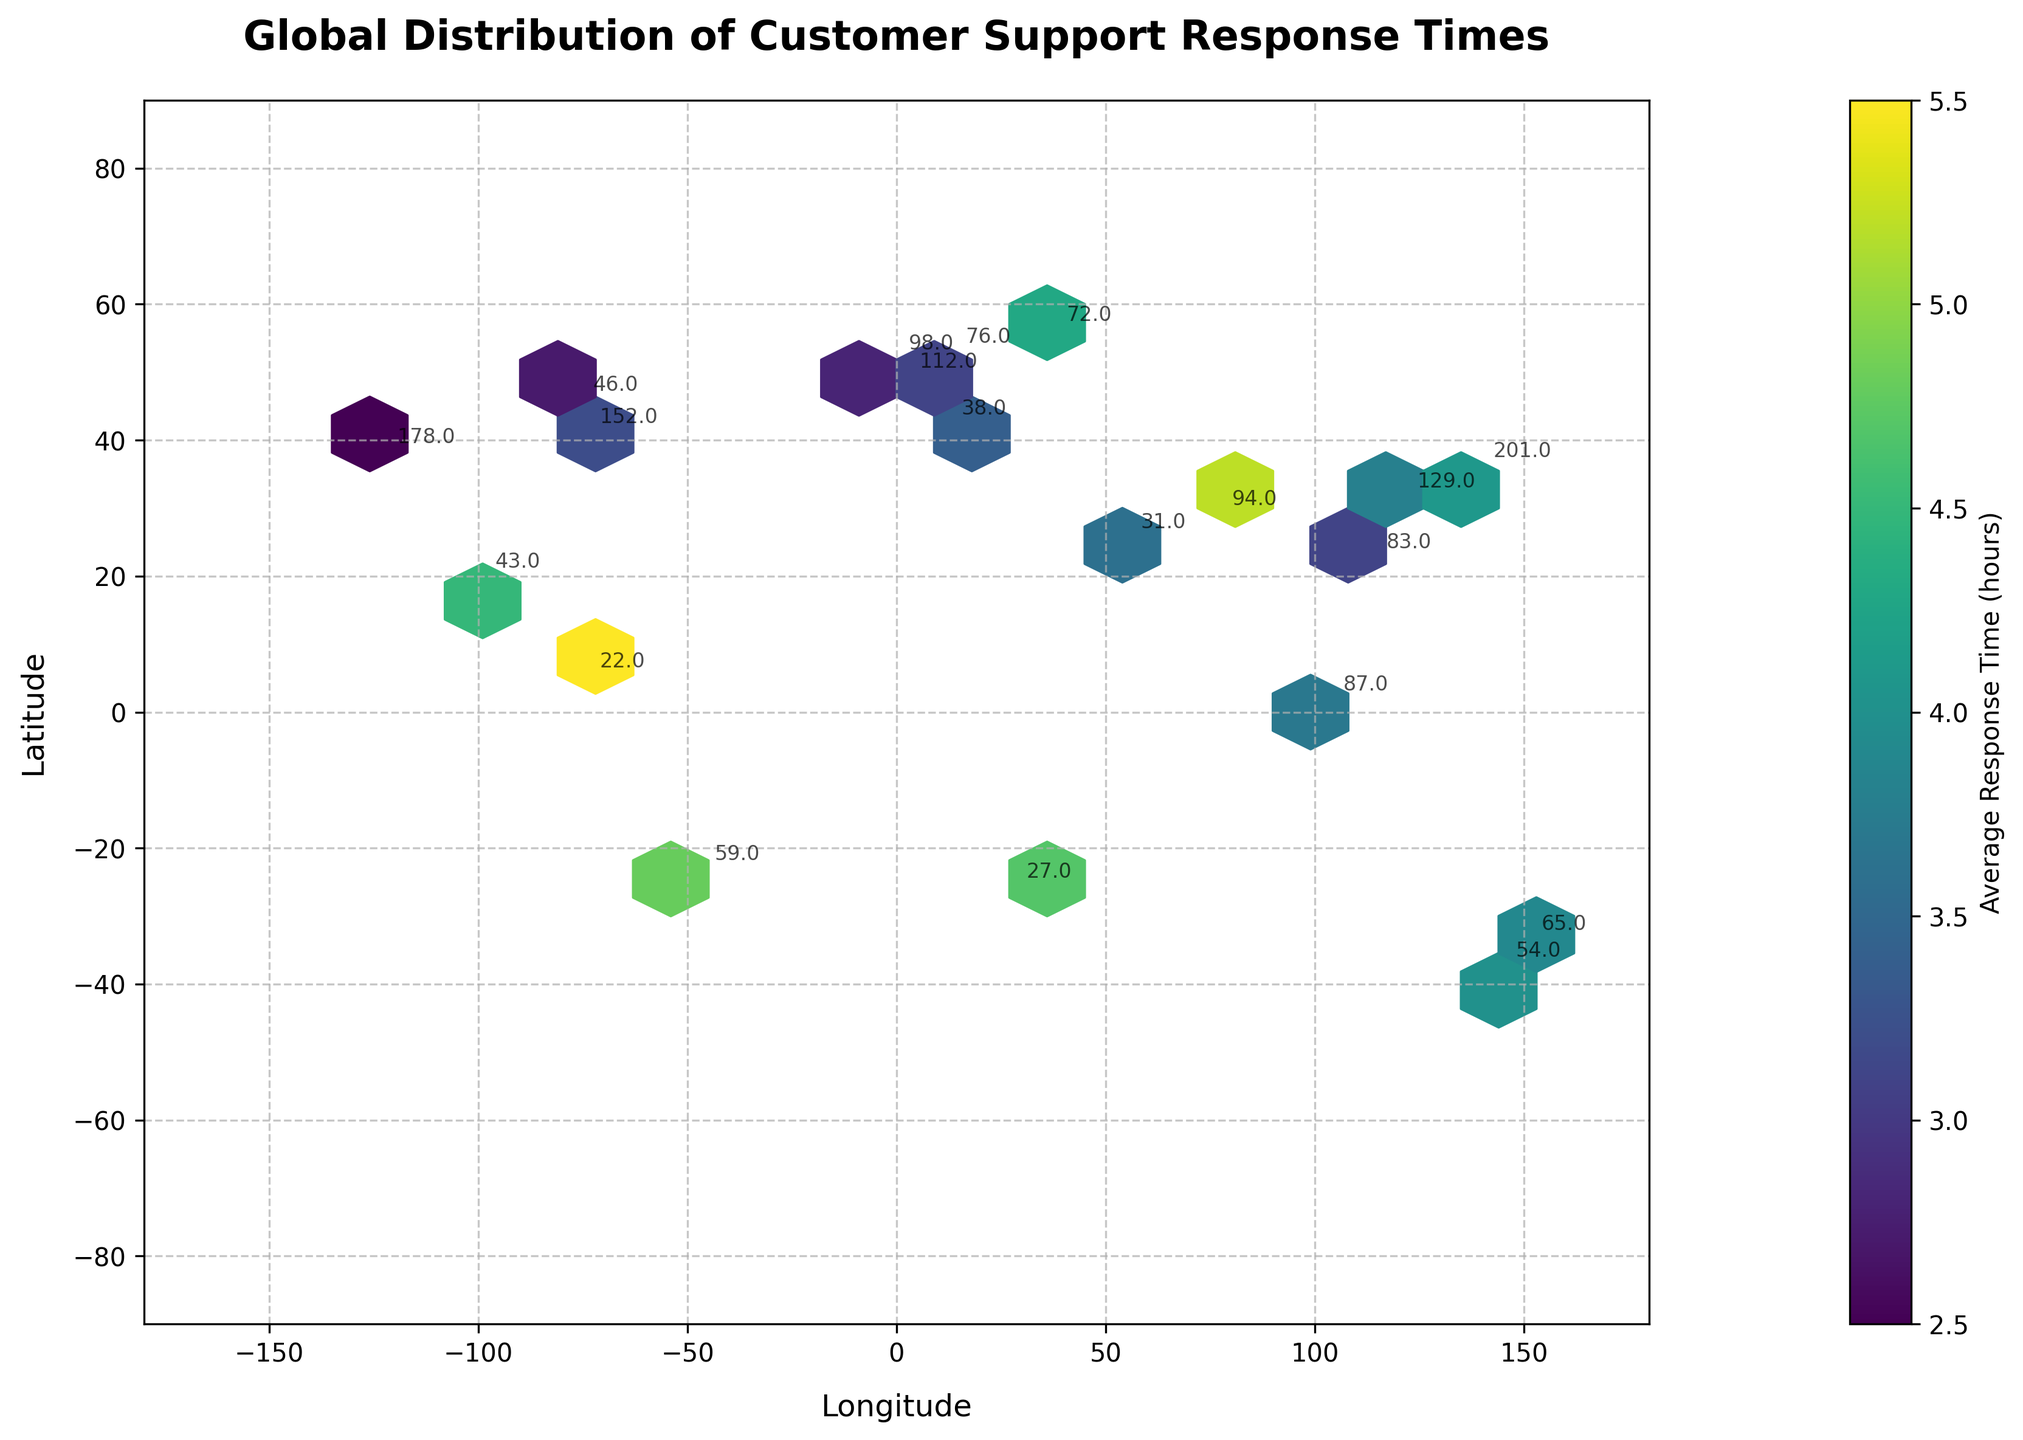How many customer support tickets were reported in London? Locate London on the plot and find the number of tickets annotated near it. London is located at approximately 51.5074° N, -0.1278° W and has 98 tickets annotated close to this location.
Answer: 98 What is the average response time for customer support in Tokyo? Locate Tokyo on the plot and find the color associated with it. Tokyo (35.6762° N, 139.6503° E) has an approximate average response time indicated by the color on the plot, which corresponds to 4.1 hours.
Answer: 4.1 hours Between New York and Paris, which city has a higher number of customer support tickets? Identify the location of New York and Paris on the plot. New York (40.7128° N, -74.0060° W) shows 152 tickets, and Paris (48.8566° N, 2.3522° E) shows 112 tickets annotated near their respective locations.
Answer: New York Compare the average response times of customer support between Berlin and Sydney. Which city's average response time is higher? Identify Berlin and Sydney on the plot. Berlin (52.5200° N, 13.4050° E) shows around 2.9 hours and Sydney (-33.8688° N, 151.2093° E) shows around 3.9 hours average response time.
Answer: Sydney How many locations have an average response time over 4 hours? Count the annotations for locations where the color indicates an average response time over 4 hours. Tokyo, Mexico City, São Paulo, Delhi, Moscow, Johannesburg, and Bogotá display colors indicating this range.
Answer: 7 locations What is the title of the hexbin plot? Read the title directly from the top section of the figure.
Answer: Global Distribution of Customer Support Response Times Which city has the fastest average response time? Identify the location with the lightest color. San Francisco (37.7749° N, -122.4194° W) has the fastest average response time, indicated by the light color and the annotation.
Answer: San Francisco What is the relationship between the number of tickets and the average response time? By observing both the density of hexagons and the color, cities with a higher number of tickets generally don't correspond to longer response times. Some high-ticket cities like New York and Tokyo have varying response times. This doesn’t suggest a clear linear relationship.
Answer: No clear linear relationship 